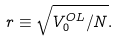<formula> <loc_0><loc_0><loc_500><loc_500>r \equiv \sqrt { V _ { 0 } ^ { O L } / N } .</formula> 